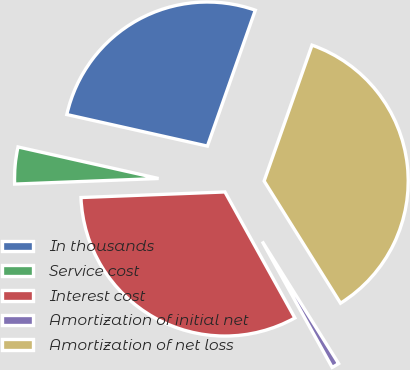Convert chart. <chart><loc_0><loc_0><loc_500><loc_500><pie_chart><fcel>In thousands<fcel>Service cost<fcel>Interest cost<fcel>Amortization of initial net<fcel>Amortization of net loss<nl><fcel>26.88%<fcel>4.13%<fcel>32.45%<fcel>0.83%<fcel>35.71%<nl></chart> 